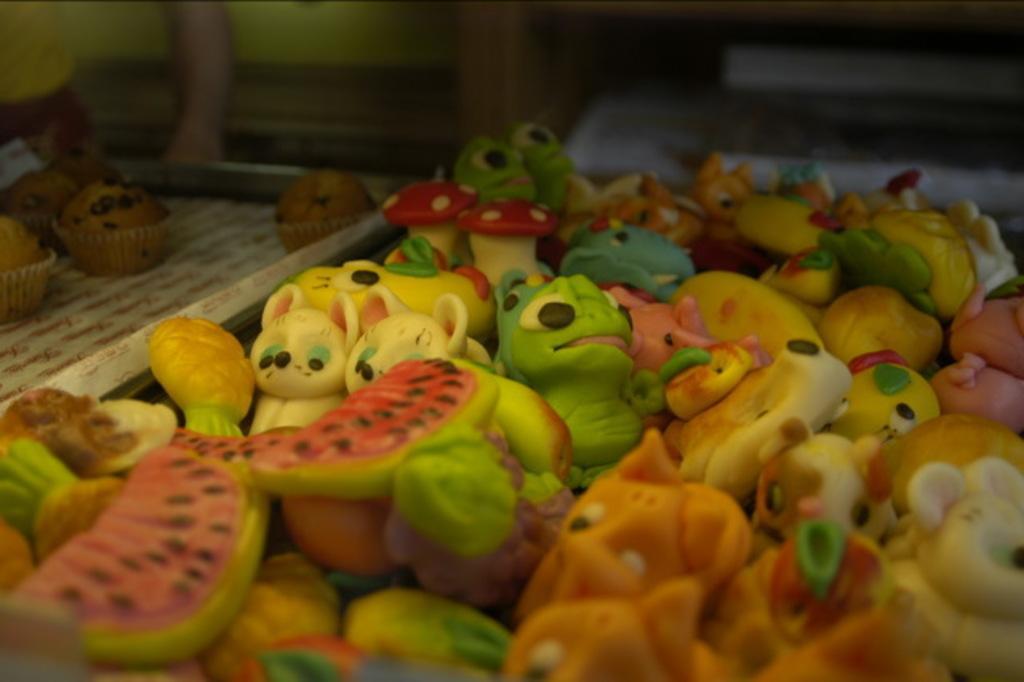How would you summarize this image in a sentence or two? In the image it seems like there are some food items in the shape of cartoons and other objects and on the left side there are cupcakes. 